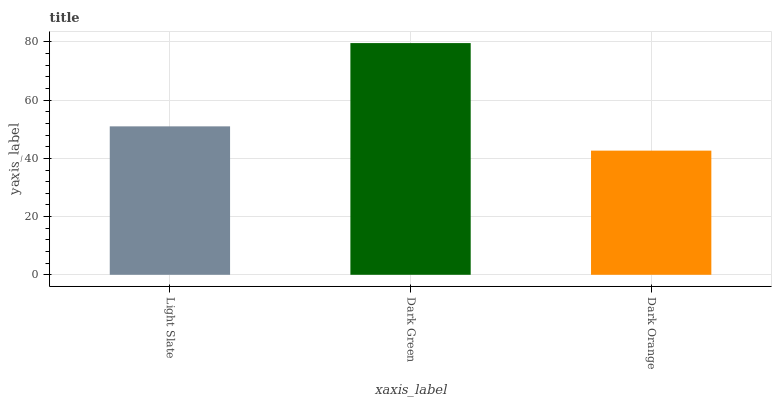Is Dark Orange the minimum?
Answer yes or no. Yes. Is Dark Green the maximum?
Answer yes or no. Yes. Is Dark Green the minimum?
Answer yes or no. No. Is Dark Orange the maximum?
Answer yes or no. No. Is Dark Green greater than Dark Orange?
Answer yes or no. Yes. Is Dark Orange less than Dark Green?
Answer yes or no. Yes. Is Dark Orange greater than Dark Green?
Answer yes or no. No. Is Dark Green less than Dark Orange?
Answer yes or no. No. Is Light Slate the high median?
Answer yes or no. Yes. Is Light Slate the low median?
Answer yes or no. Yes. Is Dark Orange the high median?
Answer yes or no. No. Is Dark Orange the low median?
Answer yes or no. No. 